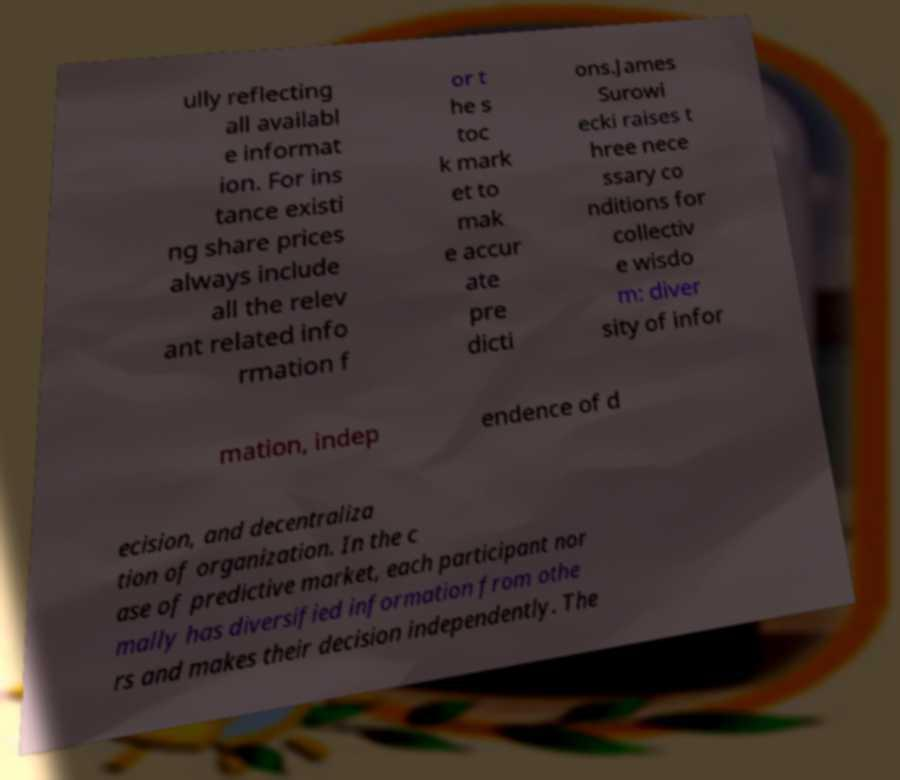Can you accurately transcribe the text from the provided image for me? ully reflecting all availabl e informat ion. For ins tance existi ng share prices always include all the relev ant related info rmation f or t he s toc k mark et to mak e accur ate pre dicti ons.James Surowi ecki raises t hree nece ssary co nditions for collectiv e wisdo m: diver sity of infor mation, indep endence of d ecision, and decentraliza tion of organization. In the c ase of predictive market, each participant nor mally has diversified information from othe rs and makes their decision independently. The 